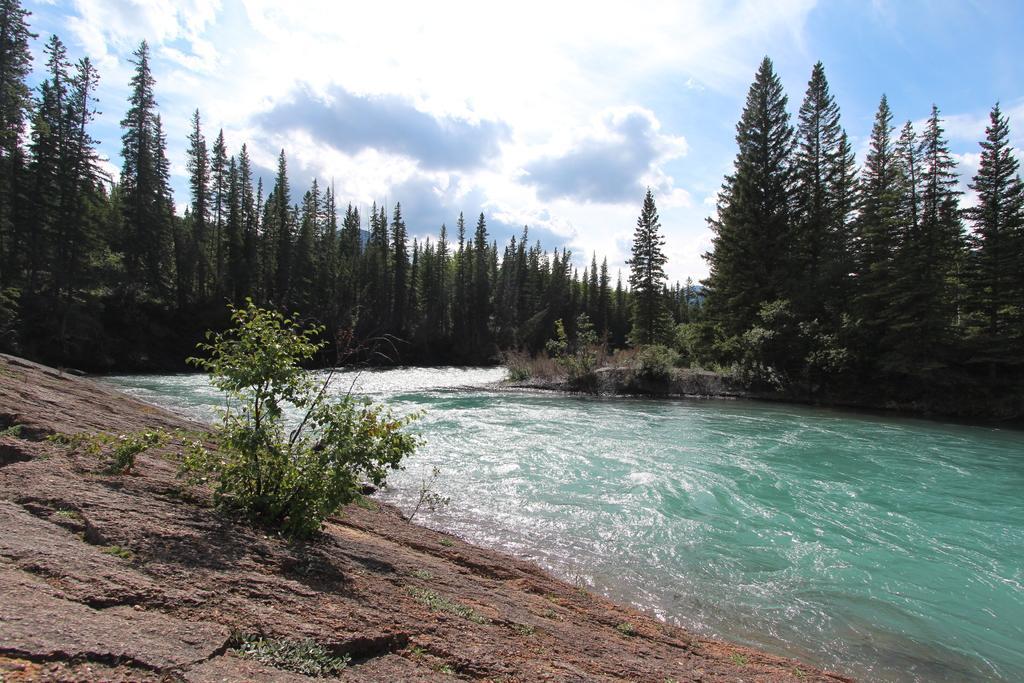How would you summarize this image in a sentence or two? In this picture we can see water flowing through the river which is surrounded by rocks, trees and blue sky. 